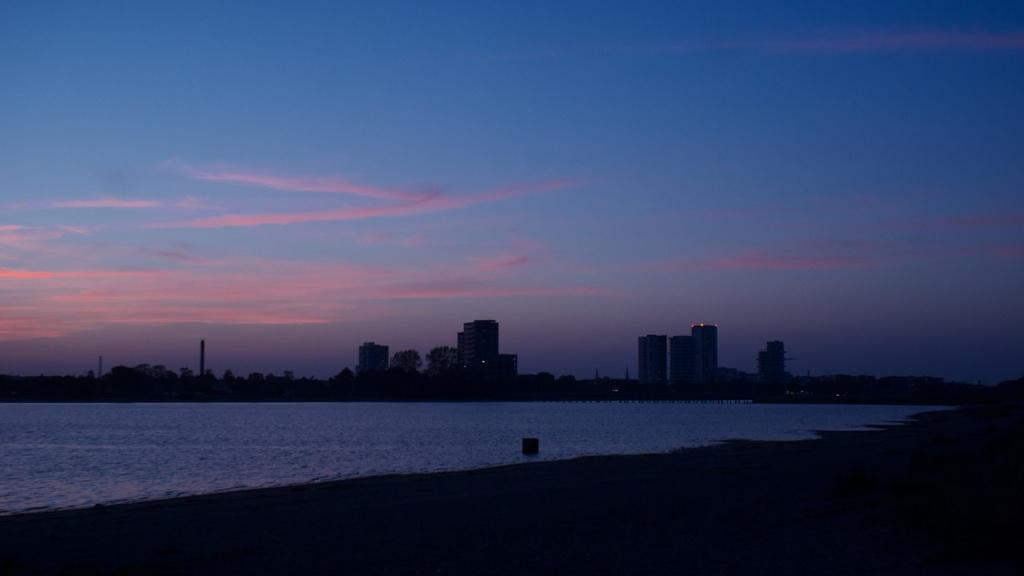What is visible in the image? Water is visible in the image. What can be seen in the background of the image? There are trees, buildings, and the sky visible in the background of the image. How many feet are visible in the image? There are no feet visible in the image. What type of frame surrounds the image? The image does not have a frame; it is a photograph or digital image without a physical frame. 